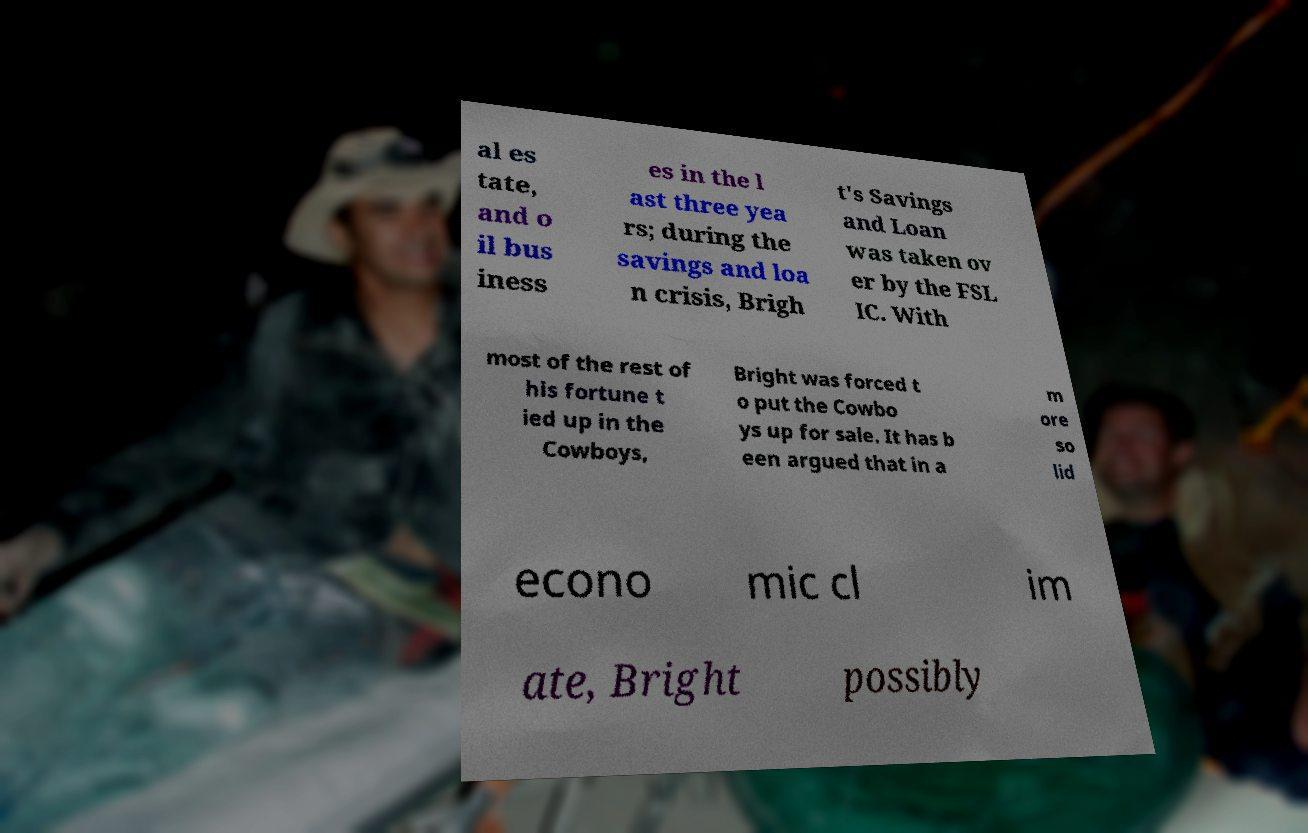For documentation purposes, I need the text within this image transcribed. Could you provide that? al es tate, and o il bus iness es in the l ast three yea rs; during the savings and loa n crisis, Brigh t's Savings and Loan was taken ov er by the FSL IC. With most of the rest of his fortune t ied up in the Cowboys, Bright was forced t o put the Cowbo ys up for sale. It has b een argued that in a m ore so lid econo mic cl im ate, Bright possibly 